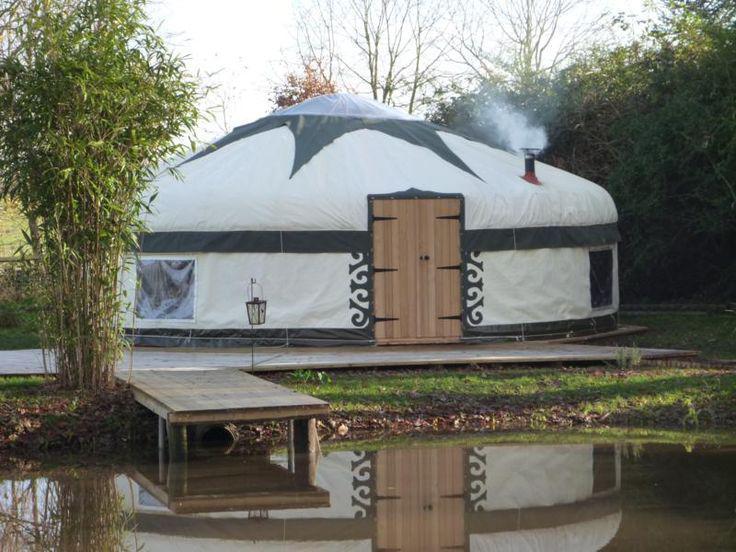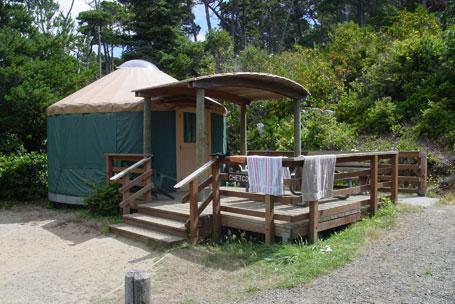The first image is the image on the left, the second image is the image on the right. Analyze the images presented: Is the assertion "Smoke is coming out of the chimney at the right side of a round building." valid? Answer yes or no. Yes. The first image is the image on the left, the second image is the image on the right. Given the left and right images, does the statement "One of the images contains a cottage with smoke coming out of its chimney." hold true? Answer yes or no. Yes. 